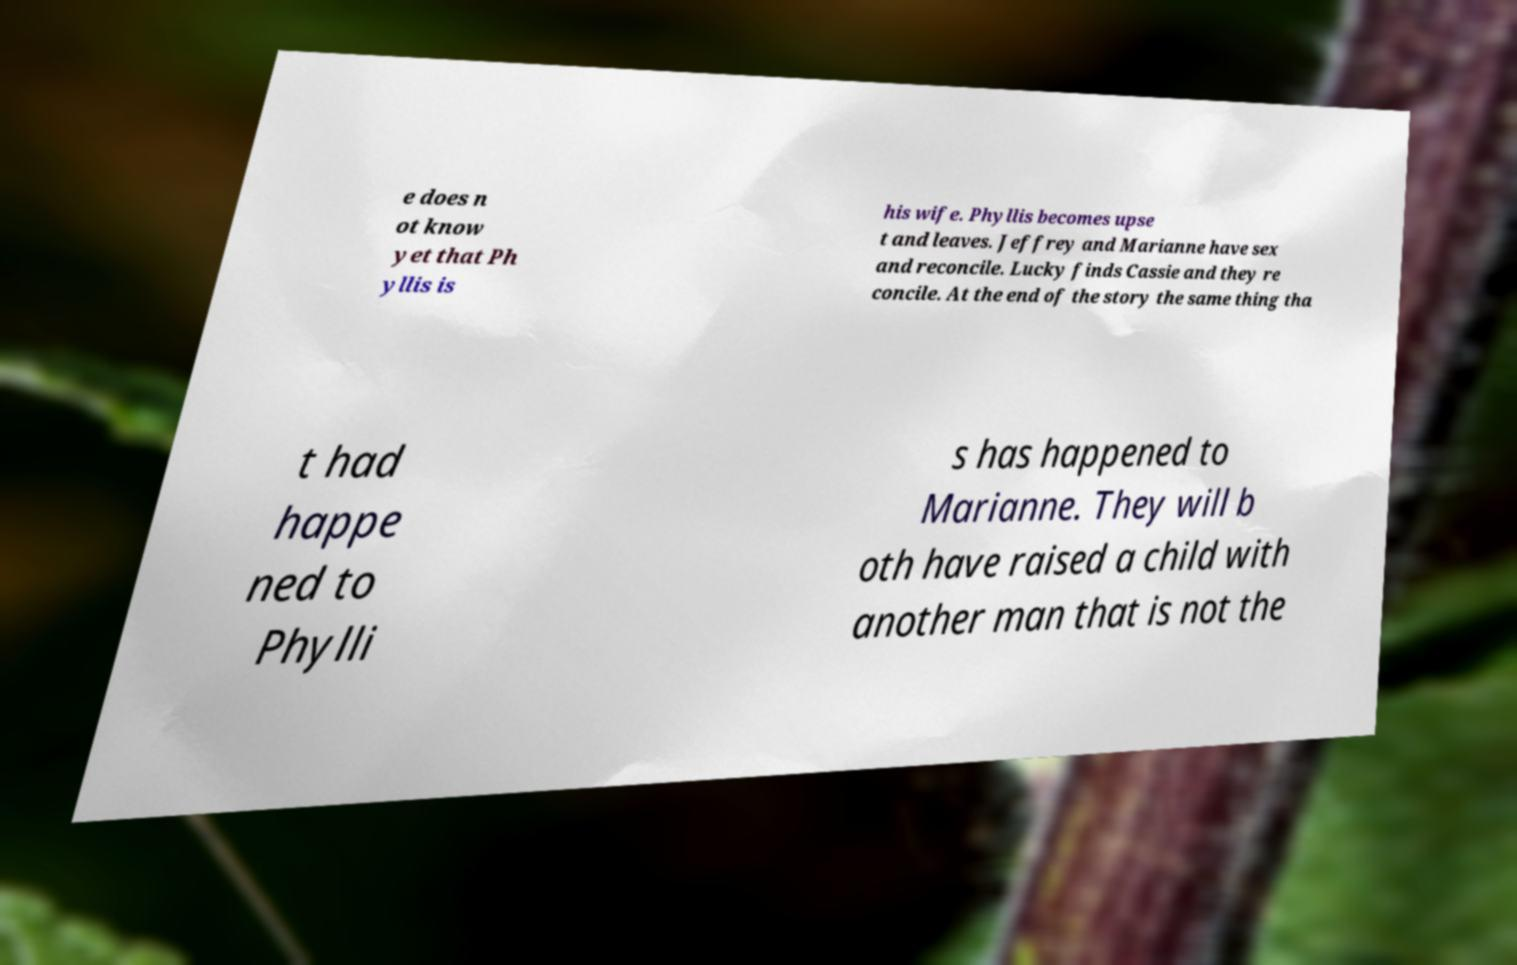Please identify and transcribe the text found in this image. e does n ot know yet that Ph yllis is his wife. Phyllis becomes upse t and leaves. Jeffrey and Marianne have sex and reconcile. Lucky finds Cassie and they re concile. At the end of the story the same thing tha t had happe ned to Phylli s has happened to Marianne. They will b oth have raised a child with another man that is not the 